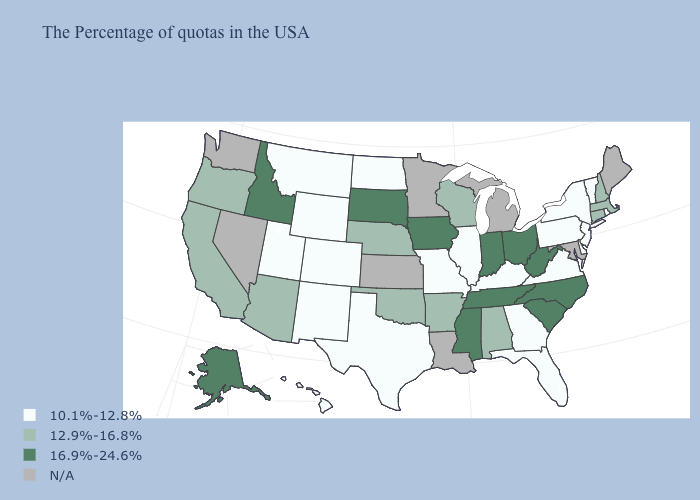Is the legend a continuous bar?
Give a very brief answer. No. What is the lowest value in the USA?
Keep it brief. 10.1%-12.8%. Among the states that border Wyoming , does Nebraska have the lowest value?
Write a very short answer. No. How many symbols are there in the legend?
Short answer required. 4. Name the states that have a value in the range N/A?
Give a very brief answer. Maine, Maryland, Michigan, Louisiana, Minnesota, Kansas, Nevada, Washington. Is the legend a continuous bar?
Write a very short answer. No. Does New York have the lowest value in the Northeast?
Quick response, please. Yes. What is the lowest value in the USA?
Concise answer only. 10.1%-12.8%. What is the value of Missouri?
Answer briefly. 10.1%-12.8%. Does the first symbol in the legend represent the smallest category?
Short answer required. Yes. Name the states that have a value in the range 12.9%-16.8%?
Be succinct. Massachusetts, New Hampshire, Connecticut, Alabama, Wisconsin, Arkansas, Nebraska, Oklahoma, Arizona, California, Oregon. What is the value of Massachusetts?
Write a very short answer. 12.9%-16.8%. Name the states that have a value in the range 10.1%-12.8%?
Keep it brief. Rhode Island, Vermont, New York, New Jersey, Delaware, Pennsylvania, Virginia, Florida, Georgia, Kentucky, Illinois, Missouri, Texas, North Dakota, Wyoming, Colorado, New Mexico, Utah, Montana, Hawaii. 